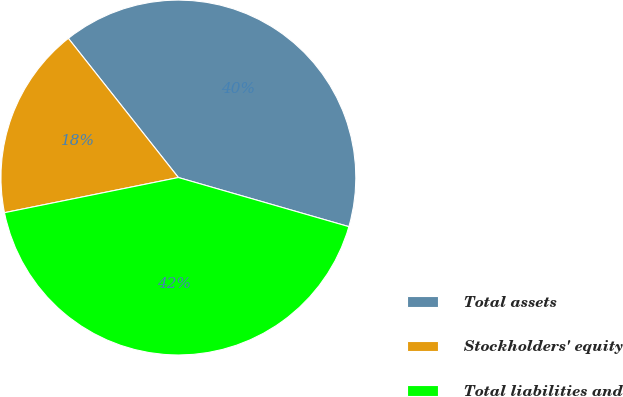Convert chart to OTSL. <chart><loc_0><loc_0><loc_500><loc_500><pie_chart><fcel>Total assets<fcel>Stockholders' equity<fcel>Total liabilities and<nl><fcel>40.11%<fcel>17.53%<fcel>42.36%<nl></chart> 